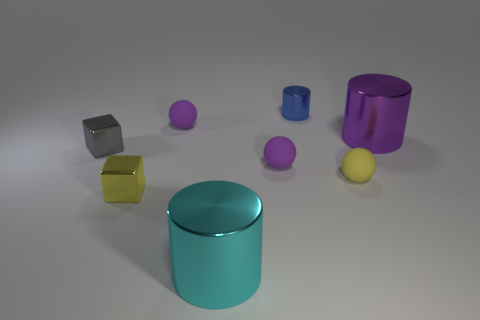Imagine animating this scene, how would you bring these objects to life? If we were to animate this scene, each object might exhibit unique characteristics to enhance their individuality. The yellow block could exhibit a cheerful bounce, resonating with its bright color. The cylinders might roll around the surface, interacting playfully with the spheres that could themselves roll away or oscillate in place. The steel cube could show refractive light properties, casting interesting reflections on the surface. The purple objects, with their vivid color, could twinkle or shimmer, adding a subtle magical element to the animation. 